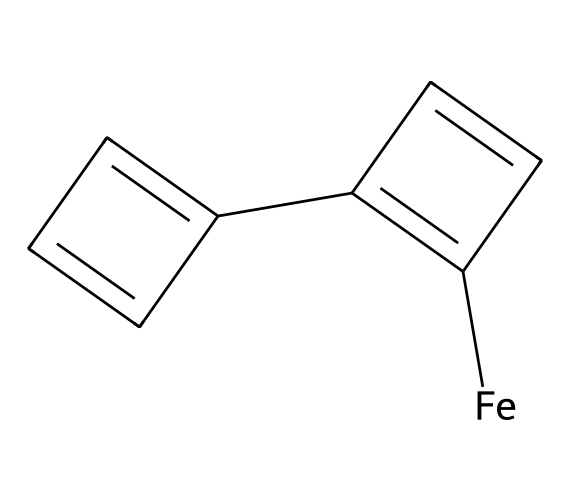What is the central metal in this compound? The SMILES indicates the presence of an iron atom, denoted by [Fe], which serves as the central metal atom in the organometallic structure of ferrocene.
Answer: iron How many carbon atoms are present in the structure? By interpreting the SMILES, we count the carbon atoms represented in the two cyclopentadienyl rings; there are ten carbon atoms in total, as each ring contains five carbon atoms and there are two rings.
Answer: ten What is the chemical functional group characterized by the iron and the cyclopentadienyl rings? The combination of the iron center with the cyclopentadienyl rings is characteristic of metallocenes, a type of organometallic compound, which features a metal sandwiched between two cyclopentadienyl anions.
Answer: metallocene How many double bonds are present in this compound? The cyclopentadienyl rings each have alternating double bonds, totaling five double bonds when combined, as each structure in the rings contributes to the pi-bonding network.
Answer: five What makes ferrocene stable as an organometallic compound? The electronic configuration and bonding arrangement allow for resonance stabilization across the cyclopentadienyl rings, coupled with the stable metal-σ bonding, which contributes to the overall stability of ferrocene in various conditions.
Answer: resonance Is this compound soluble in non-polar solvents? Due to its hydrophobic character largely stemming from the hydrocarbon nature of cyclopentadienyl rings, ferrocene is typically soluble in non-polar solvents such as hexane or toluene.
Answer: yes 